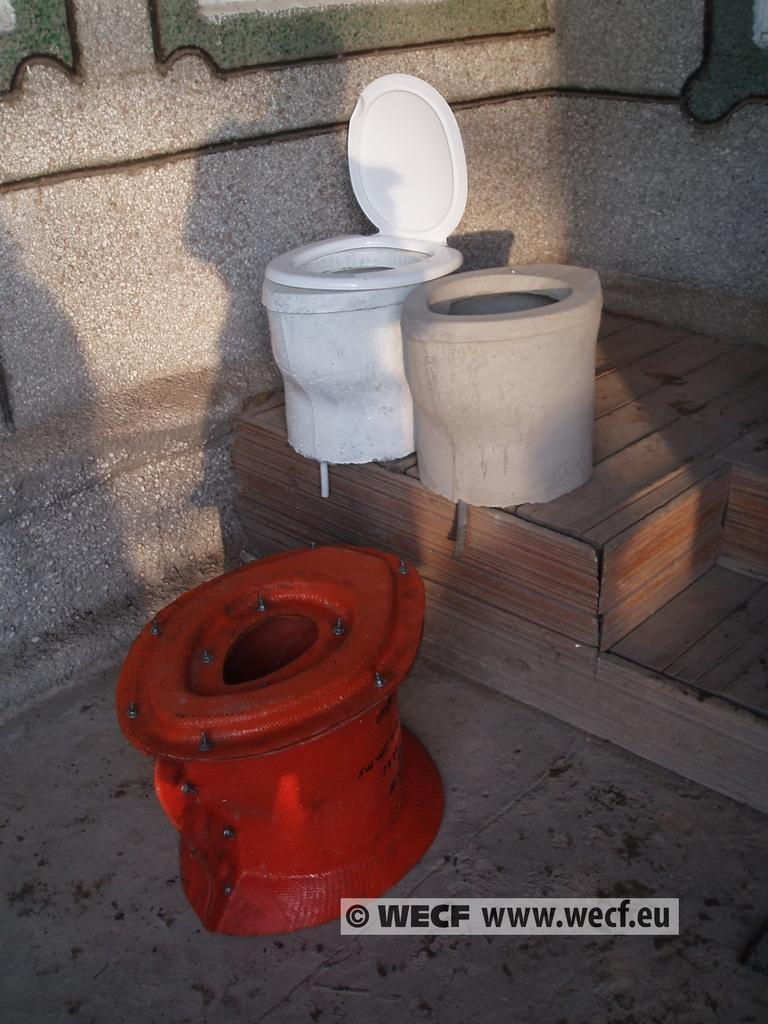Provide a one-sentence caption for the provided image. A white , ceramic toilet is next to the cast it was made from on a photo with the website www.wecf.eu in the bottom, right hand corner. 